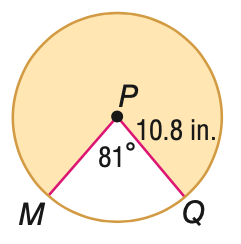Answer the mathemtical geometry problem and directly provide the correct option letter.
Question: Find the area of the shaded sector. Round to the nearest tenth, if necessary.
Choices: A: 15.3 B: 52.6 C: 82.4 D: 284.0 D 